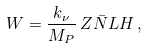Convert formula to latex. <formula><loc_0><loc_0><loc_500><loc_500>W = \frac { k _ { \nu } } { M _ { P } } \, Z \bar { N } L H \, ,</formula> 